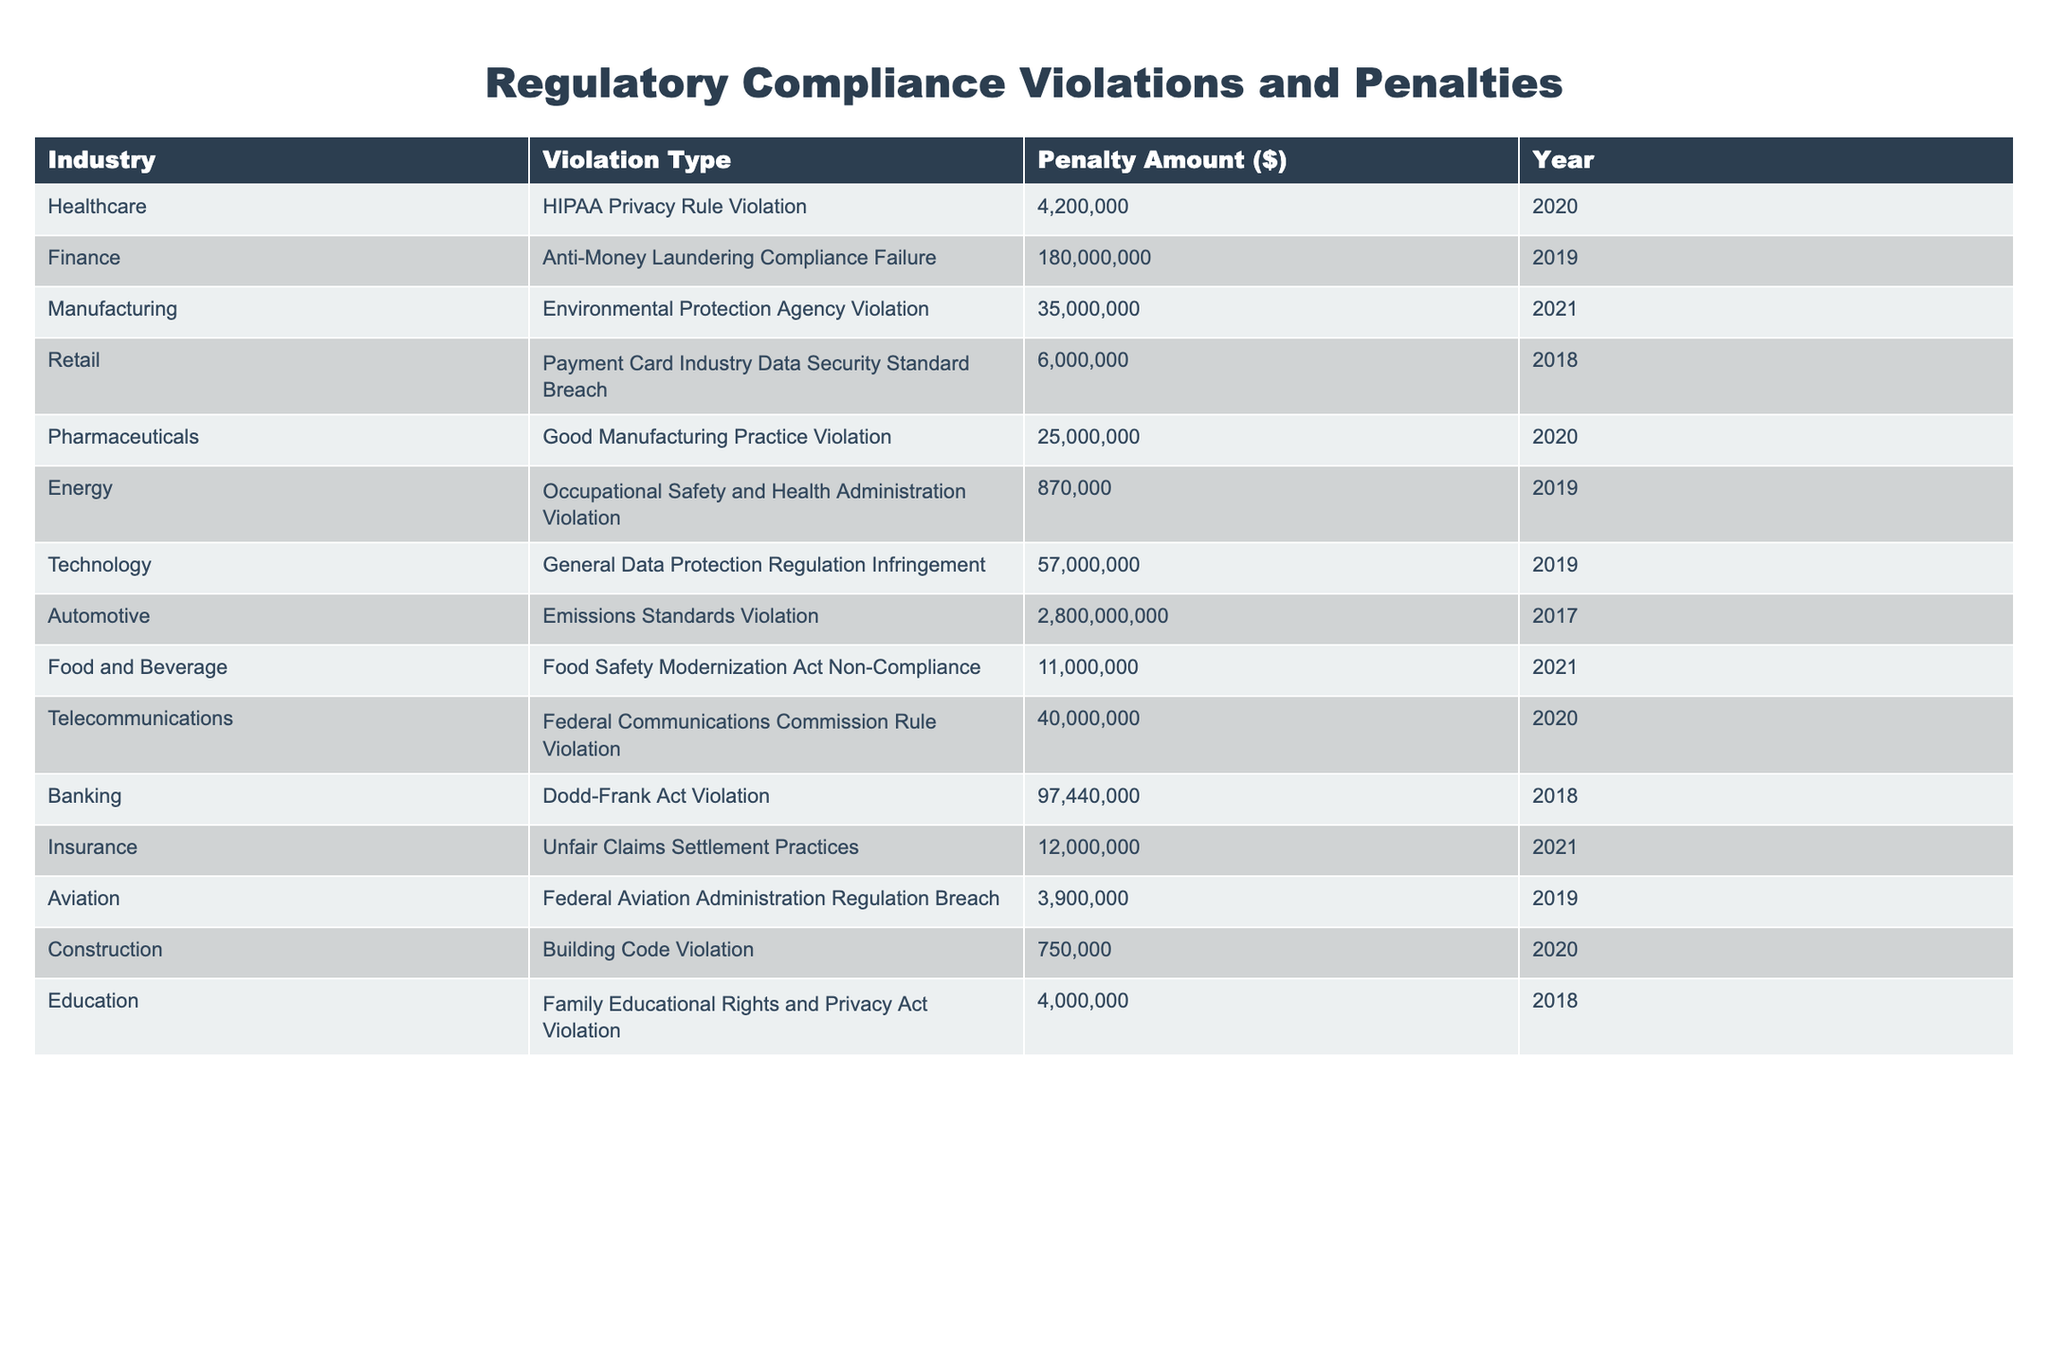What is the penalty amount for the Anti-Money Laundering Compliance Failure in the Finance industry? The table shows the penalty amount listed under the Finance industry for the Anti-Money Laundering Compliance Failure is $180,000,000.
Answer: $180,000,000 Which industry faced the largest penalty according to the table? The Automotive industry faced the largest penalty, amounting to $2,800,000,000 for Emissions Standards Violation.
Answer: Automotive What is the total penalty amount for violations in the Healthcare and Pharmaceuticals industries combined? The penalty for Healthcare is $4,200,000 and for Pharmaceuticals is $25,000,000. Adding these amounts gives $4,200,000 + $25,000,000 = $29,200,000.
Answer: $29,200,000 Is there a penalty listed for violations in the Education industry? Yes, the table indicates that there is a penalty of $4,000,000 for a violation of the Family Educational Rights and Privacy Act in the Education industry.
Answer: Yes What is the average penalty amount across all listed industries? To find the average, sum all the penalties: $4,200,000 + $180,000,000 + $35,000,000 + $6,000,000 + $25,000,000 + $870,000 + $57,000,000 + $2,800,000,000 + $11,000,000 + $40,000,000 + $97,440,000 + $12,000,000 + $3,900,000 + $750,000 + $4,000,000 = $3,158,750,000. There are 15 entries, thus the average is $3,158,750,000 / 15 = $210,583,333.33.
Answer: $210,583,333.33 How many violations were recorded in the year 2020? The table lists three violations for the year 2020: HIPAA Privacy Rule, Good Manufacturing Practice, and Federal Communications Commission Rule. Counting these gives a total of 3 violations.
Answer: 3 Which industry had a violation with a penalty under $1 million? The Energy industry had an Occupational Safety and Health Administration Violation with a penalty of $870,000, which is under $1 million.
Answer: Energy Is the penalty amount for Environmental Protection Agency Violation less than $40 million? No, the penalty amount for Environmental Protection Agency Violation is $35,000,000, which is less than $40 million.
Answer: Yes What is the difference in penalty amounts between the highest and the lowest penalties listed? The highest penalty is $2,800,000,000 for the Automotive industry and the lowest penalty is $750,000 for the Construction industry. The difference is $2,800,000,000 - $750,000 = $2,799,250,000.
Answer: $2,799,250,000 Which compliance violation resulted in the penalty of $11 million? The Food and Beverage industry faced a penalty of $11,000,000 for the Food Safety Modernization Act Non-Compliance.
Answer: Food Safety Modernization Act Non-Compliance Did any industry receive penalties in multiple years according to the table? Yes, the Telecommunications industry received penalties in 2020, while the Finance industry received its penalty in 2019.
Answer: No 